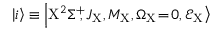Convert formula to latex. <formula><loc_0><loc_0><loc_500><loc_500>\left | i \right > \equiv \left | X ^ { 2 } \Sigma ^ { + } \, , J _ { X } , M _ { X } , \Omega _ { X } \, = \, 0 , \mathcal { E } _ { X } \right ></formula> 